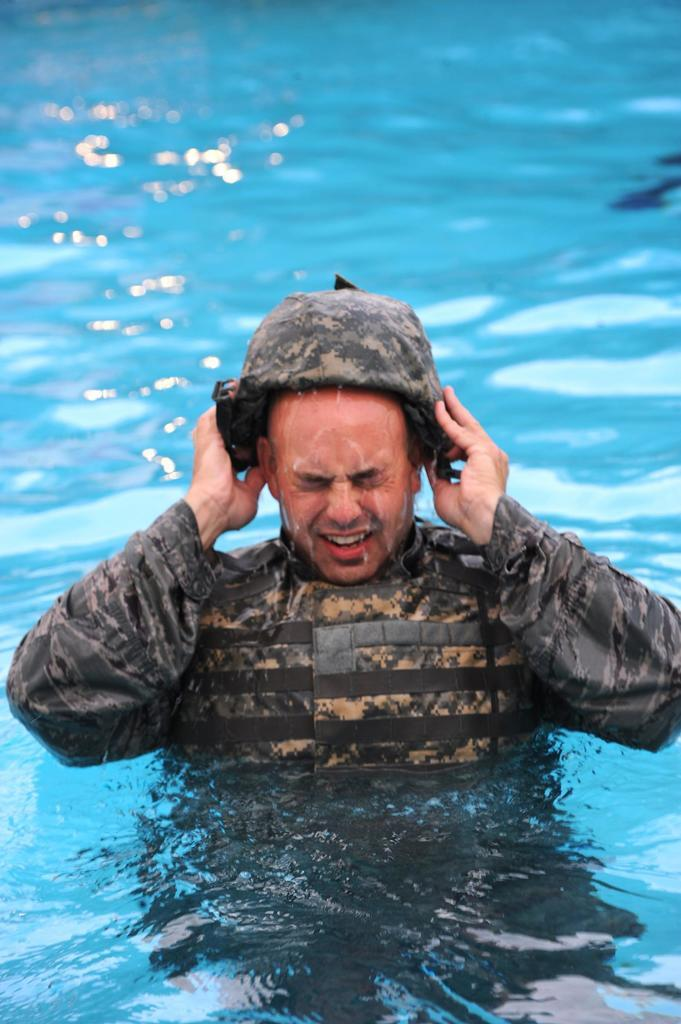Who is present in the image? There is a person in the image. What is the person wearing? The person is wearing a dress and cap. Where is the person located in the image? The person is in a swimming pool. What type of cactus can be seen growing in the swimming pool? There is no cactus present in the image; the person is in a swimming pool. 